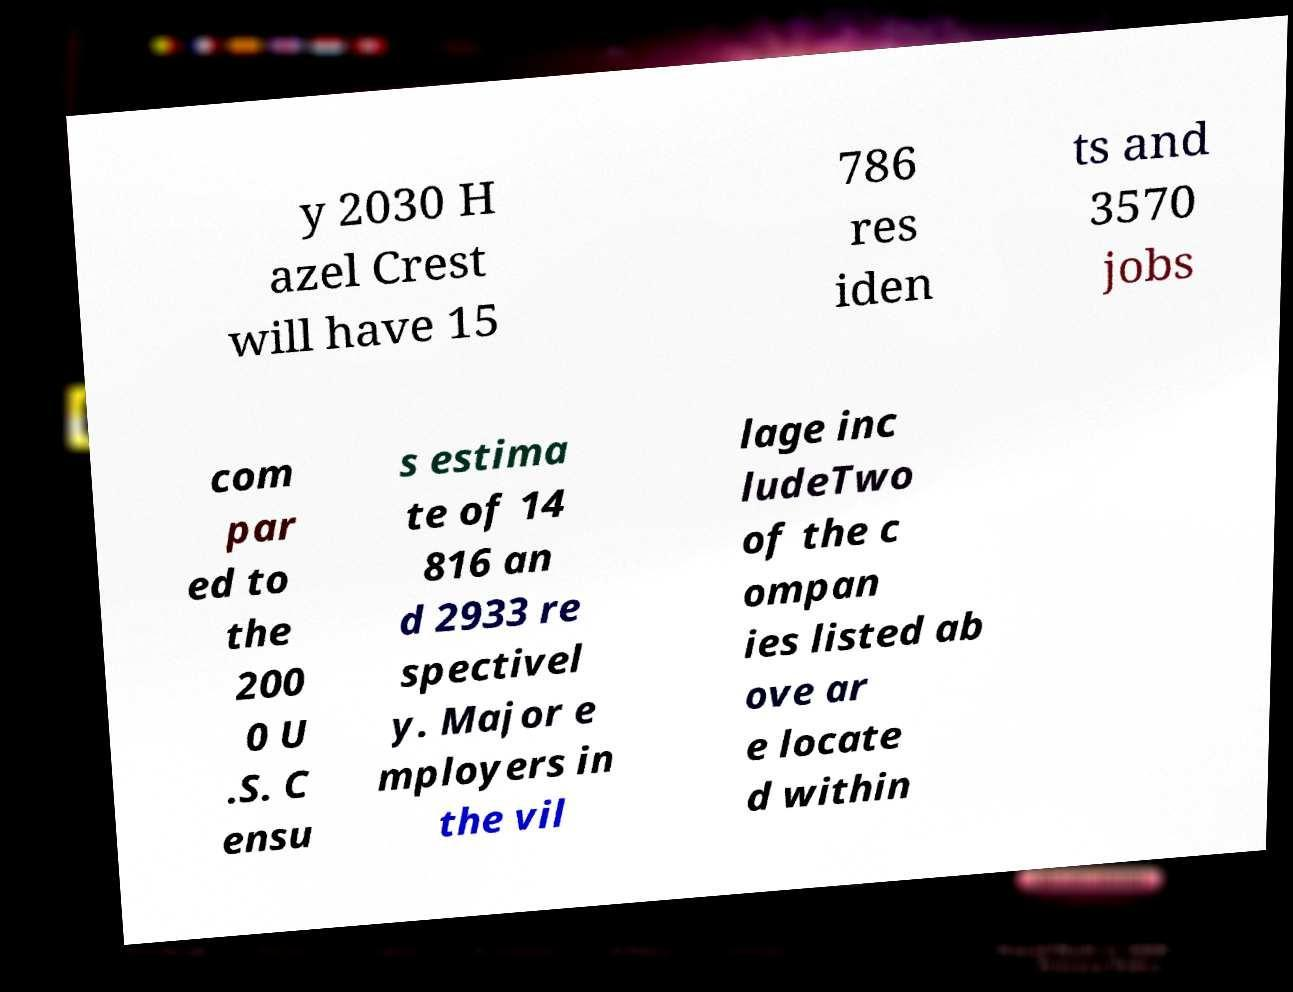Could you extract and type out the text from this image? y 2030 H azel Crest will have 15 786 res iden ts and 3570 jobs com par ed to the 200 0 U .S. C ensu s estima te of 14 816 an d 2933 re spectivel y. Major e mployers in the vil lage inc ludeTwo of the c ompan ies listed ab ove ar e locate d within 